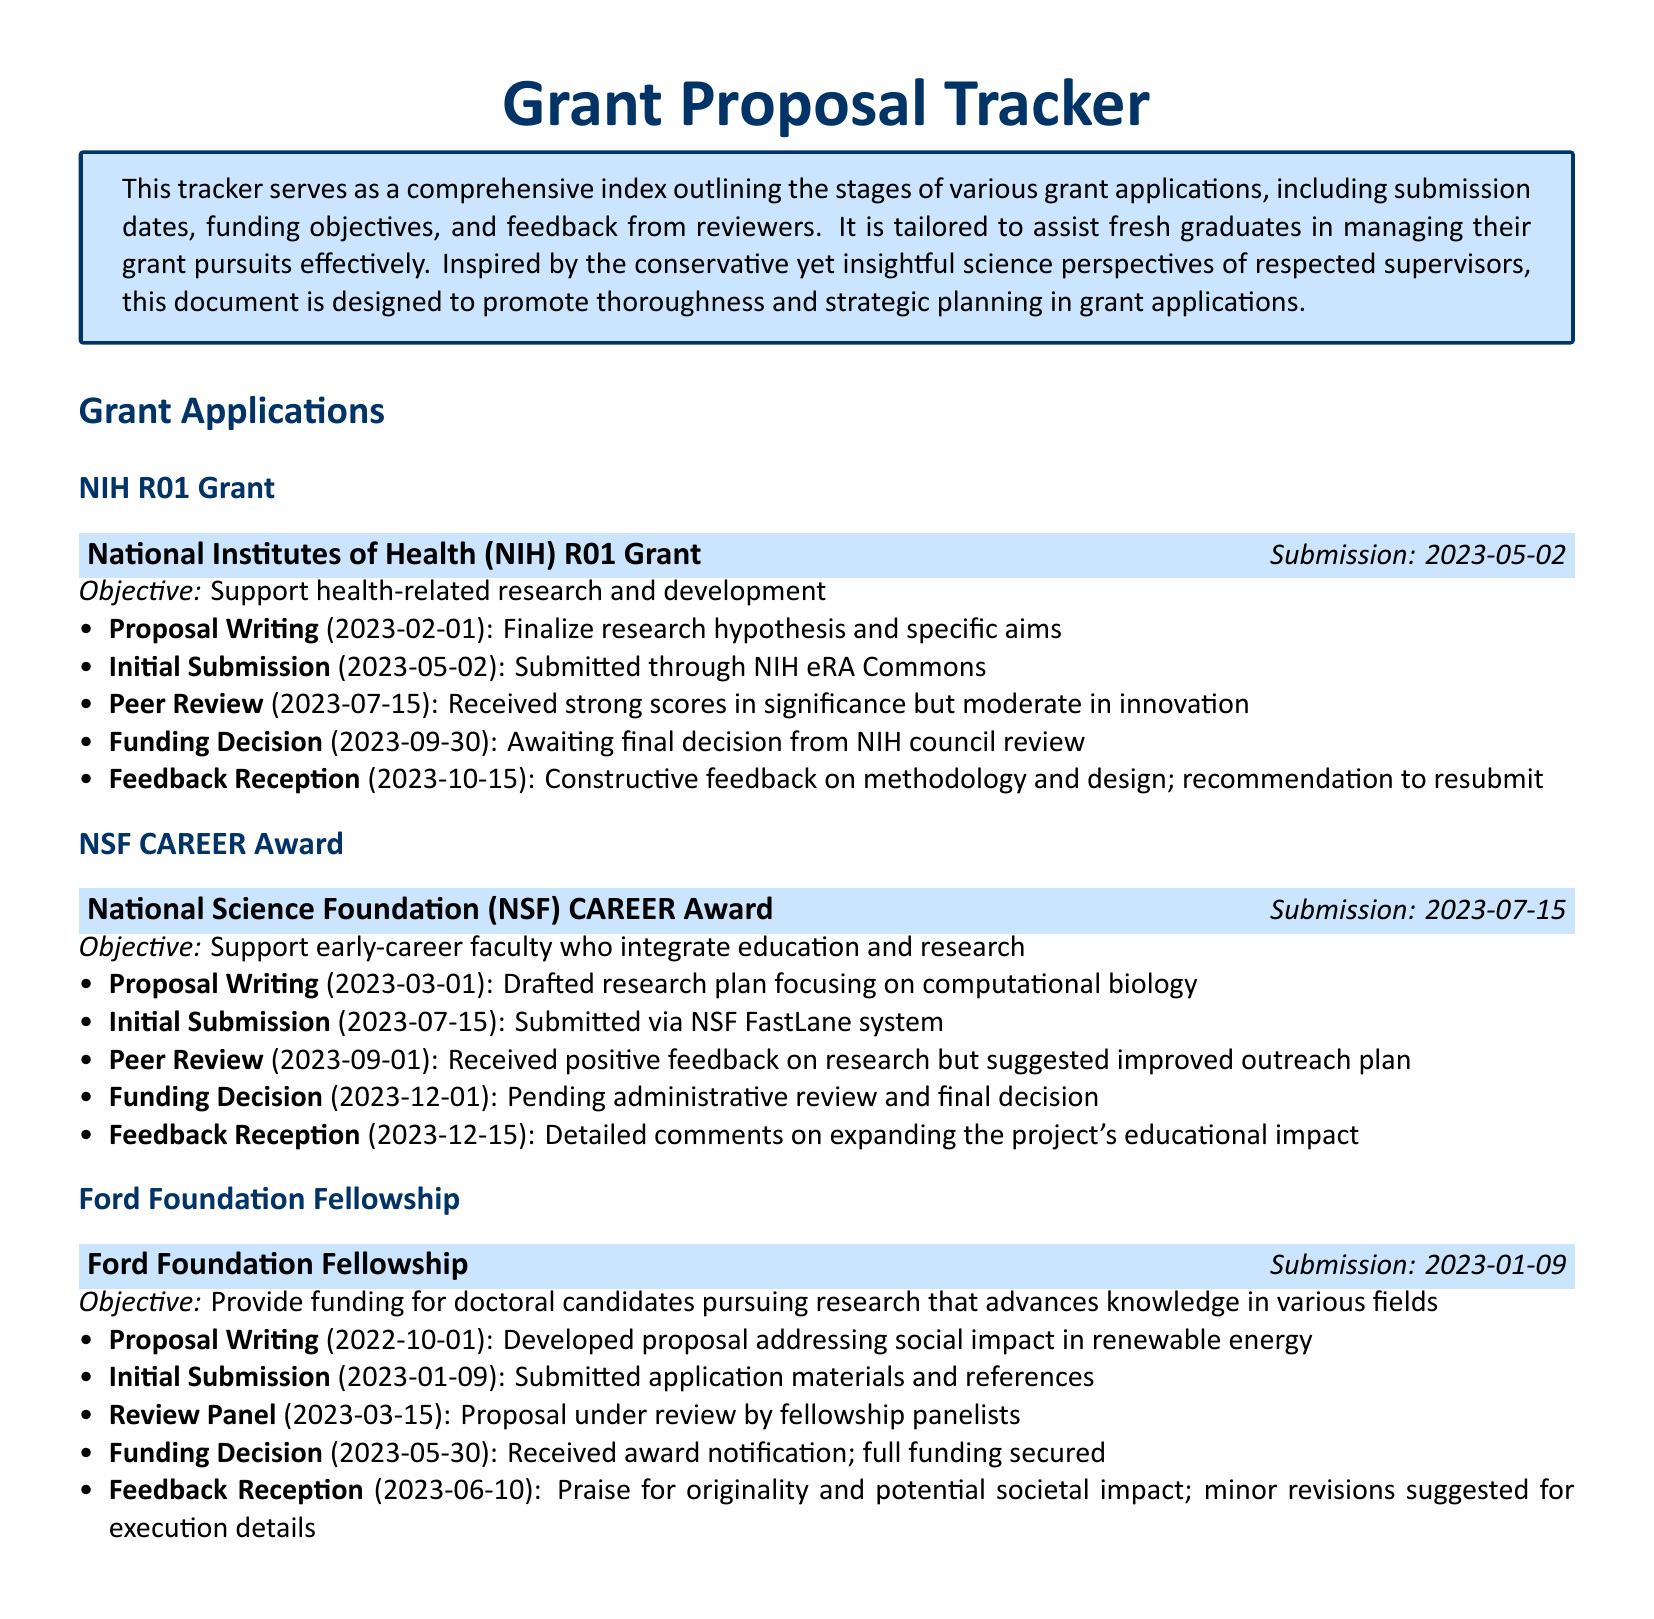what is the submission date for the NIH R01 Grant? The submission date is mentioned explicitly in the document under the NIH R01 Grant section.
Answer: 2023-05-02 what is the funding objective of the NSF CAREER Award? The funding objective is clearly stated in relation to the NSF CAREER Award.
Answer: Support early-career faculty who integrate education and research who is the funding body for the Ford Foundation Fellowship? The funding body is identified at the beginning of the Ford Foundation Fellowship section.
Answer: Ford Foundation what feedback was received for the NSF CAREER Award in the peer review stage? The feedback is detailed under the peer review stage of the NSF CAREER Award section.
Answer: Positive feedback on research but suggested improved outreach plan when was the funding decision for the Ford Foundation Fellowship made? The date of the funding decision is explicitly included in the Ford Foundation Fellowship section.
Answer: 2023-05-30 what stage comes after the initial submission for the NIH R01 Grant? The sequence of stages is provided in the NIH R01 Grant section.
Answer: Peer Review how many stages are documented for the NSF CAREER Award? The number of stages can be counted in the NSF CAREER Award section.
Answer: 5 what type of feedback was received for the Ford Foundation Fellowship after review? The type of feedback is described under the feedback reception stage in the Ford Foundation Fellowship section.
Answer: Praise for originality and potential societal impact what is the initial submission date for the NSF CAREER Award? The initial submission date is specified in the NSF CAREER Award section.
Answer: 2023-07-15 